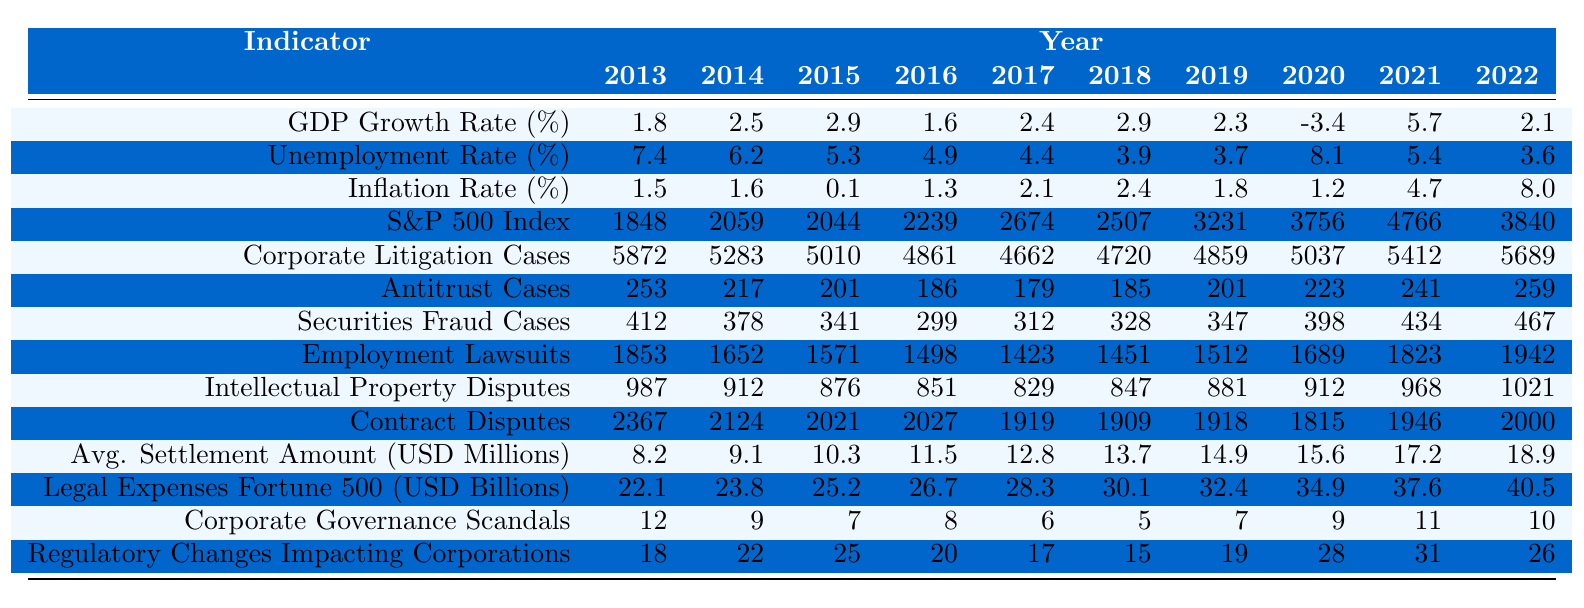What was the GDP growth rate in 2019? The table shows that the GDP growth rate in 2019 is listed under the "GDP Growth Rate (%)" row for the year 2019. The value is 2.3.
Answer: 2.3 How many corporate litigation cases were there in 2020? Referring to the row for "Corporate Litigation Cases," the value for the year 2020 is found. It shows there were 5037 cases.
Answer: 5037 What is the average inflation rate from 2013 to 2022? To find the average inflation rate over these years, I will sum the inflation rates for each year (1.5 + 1.6 + 0.1 + 1.3 + 2.1 + 2.4 + 1.8 + 1.2 + 4.7 + 8.0) which totals 25.7, and then divide by the number of years (10). Thus, the average is 25.7/10 = 2.57.
Answer: 2.57 Did the unemployment rate drop below 4% at any point in the last decade? Checking the "Unemployment Rate (%)" row, the lowest rate is 3.6 in 2022, which indicates that it did fall below 4%.
Answer: Yes Which year had the highest average settlement amount, and what was that amount? Looking at the "Avg. Settlement Amount (USD Millions)" row, the highest value is for 2022, which is 18.9 million USD.
Answer: 2022, 18.9 How many antitrust cases were there in 2015 compared to 2021? Referring to the "Antitrust Cases" row, there were 201 cases in 2015 and 241 cases in 2021. The comparison shows an increase of 40 cases.
Answer: 40 more cases in 2021 Was there a year when the average settlement amount was lower than 10 million? By examining the "Avg. Settlement Amount (USD Millions)" row, I can see that the average settlement amount was below 10 million in every year from 2013 to 2015.
Answer: Yes What trend can be observed in corporate litigation cases from 2013 to 2022? The values for "Corporate Litigation Cases" show a declining trend from 2013 (5872) to 2017 (4662), followed by an increase in the following years, culminating at 5689 in 2022.
Answer: Declining then increasing What was the correlation between GDP growth rate and the number of corporate litigation cases between 2013 and 2022? By analyzing the GDP growth rates and the corporate litigation cases in the respective years, we note that higher GDP growth rates in certain years do not consistently correlate with lower litigation cases; instead, they fluctuate independently throughout the decade.
Answer: No consistent correlation What was the change in legal expenses for Fortune 500 companies from 2013 to 2022? According to the "Legal Expenses Fortune 500 (USD Billions)" row, legal expenses increased from 22.1 billion in 2013 to 40.5 billion in 2022, which is a difference of 18.4 billion.
Answer: 18.4 billion increase 